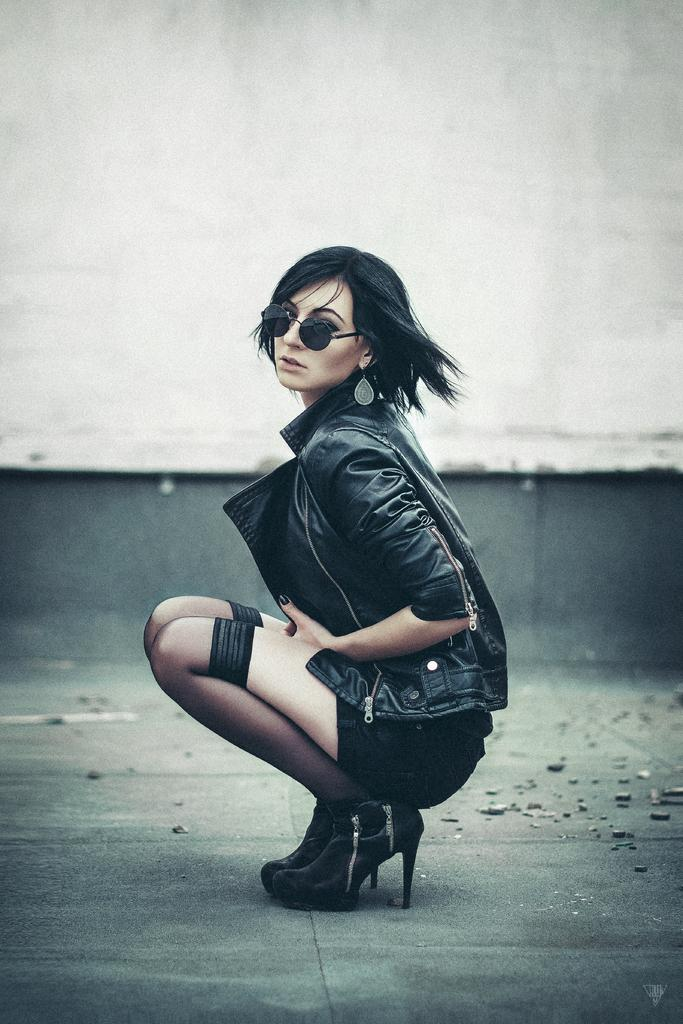Who is the main subject in the image? There is a woman in the center of the picture. What is the woman wearing? The woman is wearing a black dress. What can be seen on the ground at the bottom of the image? There are stones on the ground at the bottom of the image. What is visible in the background of the image? There is a well in the background of the image. What type of structure is the woman holding in the image? There is no structure visible in the woman's hands in the image. How many baskets can be seen in the image? There are no baskets present in the image. 